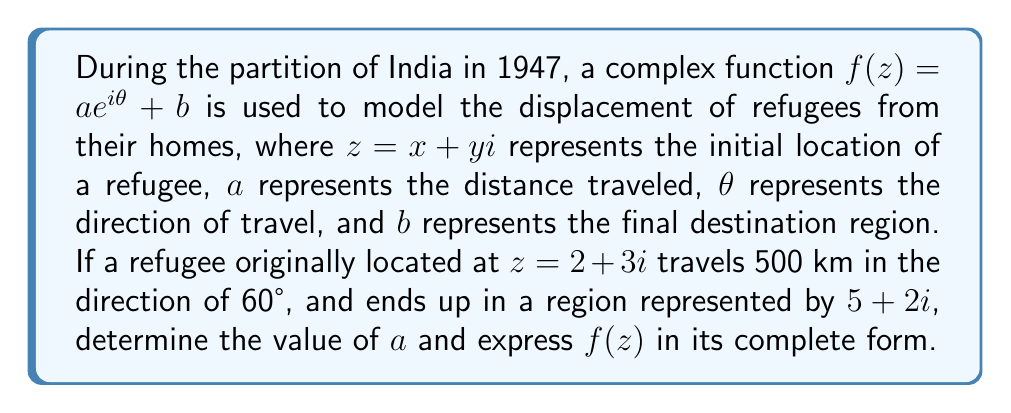Could you help me with this problem? Let's approach this step-by-step:

1) We are given that $f(z) = ae^{i\theta} + b$, where:
   - $a = 500$ (distance traveled in km)
   - $\theta = 60°$ (direction of travel)
   - $b = 5 + 2i$ (final destination region)

2) To express $e^{i\theta}$ in rectangular form:
   $$e^{i\theta} = \cos\theta + i\sin\theta$$
   $$e^{i(60°)} = \cos60° + i\sin60° = \frac{1}{2} + i\frac{\sqrt{3}}{2}$$

3) Now we can write $f(z)$ in its complete form:
   $$f(z) = 500(\frac{1}{2} + i\frac{\sqrt{3}}{2}) + (5 + 2i)$$

4) Simplifying:
   $$f(z) = (250 + 5) + (250\sqrt{3} + 2)i$$
   $$f(z) = 255 + (250\sqrt{3} + 2)i$$

5) Therefore, the complete form of $f(z)$ is:
   $$f(z) = 255 + (250\sqrt{3} + 2)i$$
Answer: $f(z) = 255 + (250\sqrt{3} + 2)i$ 